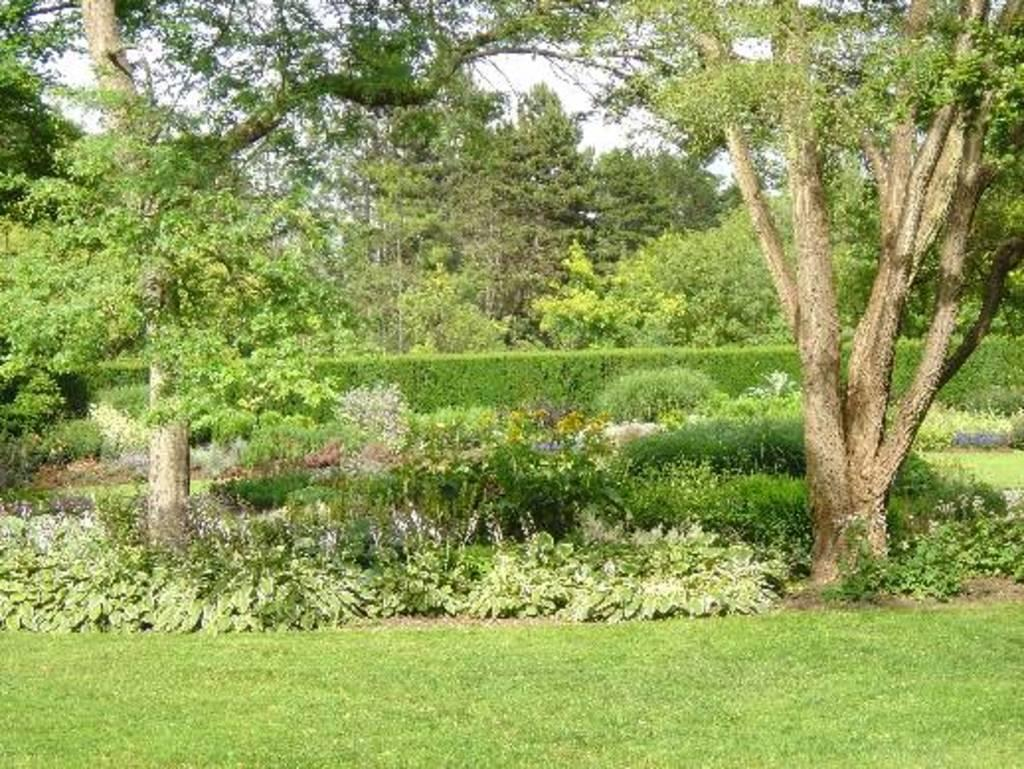What type of environment is depicted in the image? The image is an outside view. What type of vegetation is visible at the bottom of the image? There is grass visible at the bottom of the image. What other types of vegetation can be seen in the background of the image? There are plants and trees in the background of the image. How does the tree in the image stop the car from moving forward? There is no car present in the image, and the tree is not interacting with any vehicle. 